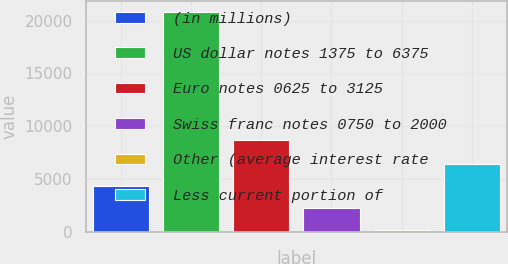Convert chart. <chart><loc_0><loc_0><loc_500><loc_500><bar_chart><fcel>(in millions)<fcel>US dollar notes 1375 to 6375<fcel>Euro notes 0625 to 3125<fcel>Swiss franc notes 0750 to 2000<fcel>Other (average interest rate<fcel>Less current portion of<nl><fcel>4307.8<fcel>20819<fcel>8656<fcel>2243.9<fcel>180<fcel>6371.7<nl></chart> 